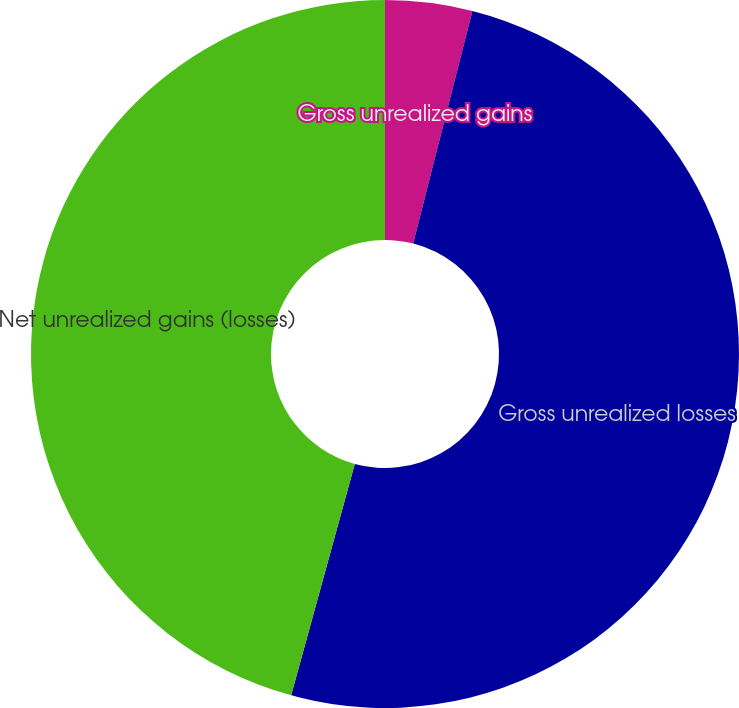Convert chart. <chart><loc_0><loc_0><loc_500><loc_500><pie_chart><fcel>Gross unrealized gains<fcel>Gross unrealized losses<fcel>Net unrealized gains (losses)<nl><fcel>3.97%<fcel>50.3%<fcel>45.73%<nl></chart> 